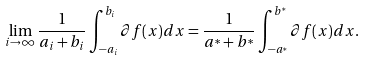Convert formula to latex. <formula><loc_0><loc_0><loc_500><loc_500>\lim _ { i \to \infty } \frac { 1 } { a _ { i } + b _ { i } } \int _ { - a _ { i } } ^ { b _ { i } } \partial f ( x ) d x = \frac { 1 } { a ^ { * } + b ^ { * } } \int _ { - a ^ { * } } ^ { b ^ { * } } \partial f ( x ) d x .</formula> 